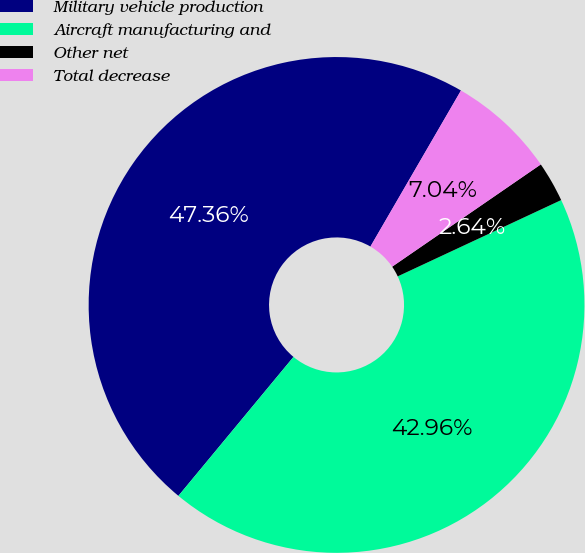<chart> <loc_0><loc_0><loc_500><loc_500><pie_chart><fcel>Military vehicle production<fcel>Aircraft manufacturing and<fcel>Other net<fcel>Total decrease<nl><fcel>47.36%<fcel>42.96%<fcel>2.64%<fcel>7.04%<nl></chart> 